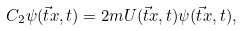<formula> <loc_0><loc_0><loc_500><loc_500>C _ { 2 } \psi ( \vec { t } { x } , t ) = 2 m U ( \vec { t } { x } , t ) \psi ( \vec { t } { x } , t ) ,</formula> 